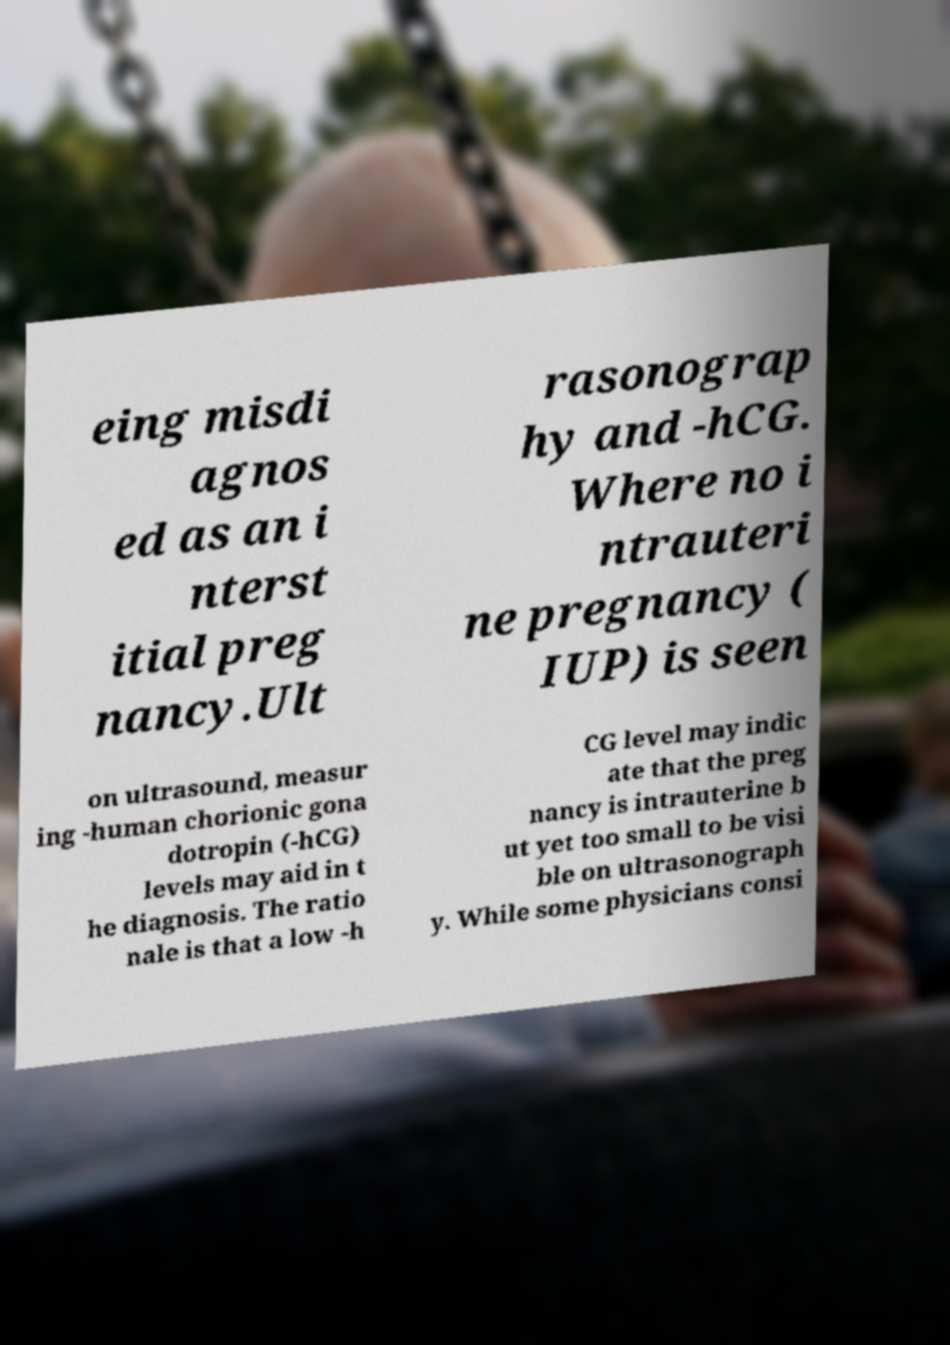Could you extract and type out the text from this image? eing misdi agnos ed as an i nterst itial preg nancy.Ult rasonograp hy and -hCG. Where no i ntrauteri ne pregnancy ( IUP) is seen on ultrasound, measur ing -human chorionic gona dotropin (-hCG) levels may aid in t he diagnosis. The ratio nale is that a low -h CG level may indic ate that the preg nancy is intrauterine b ut yet too small to be visi ble on ultrasonograph y. While some physicians consi 